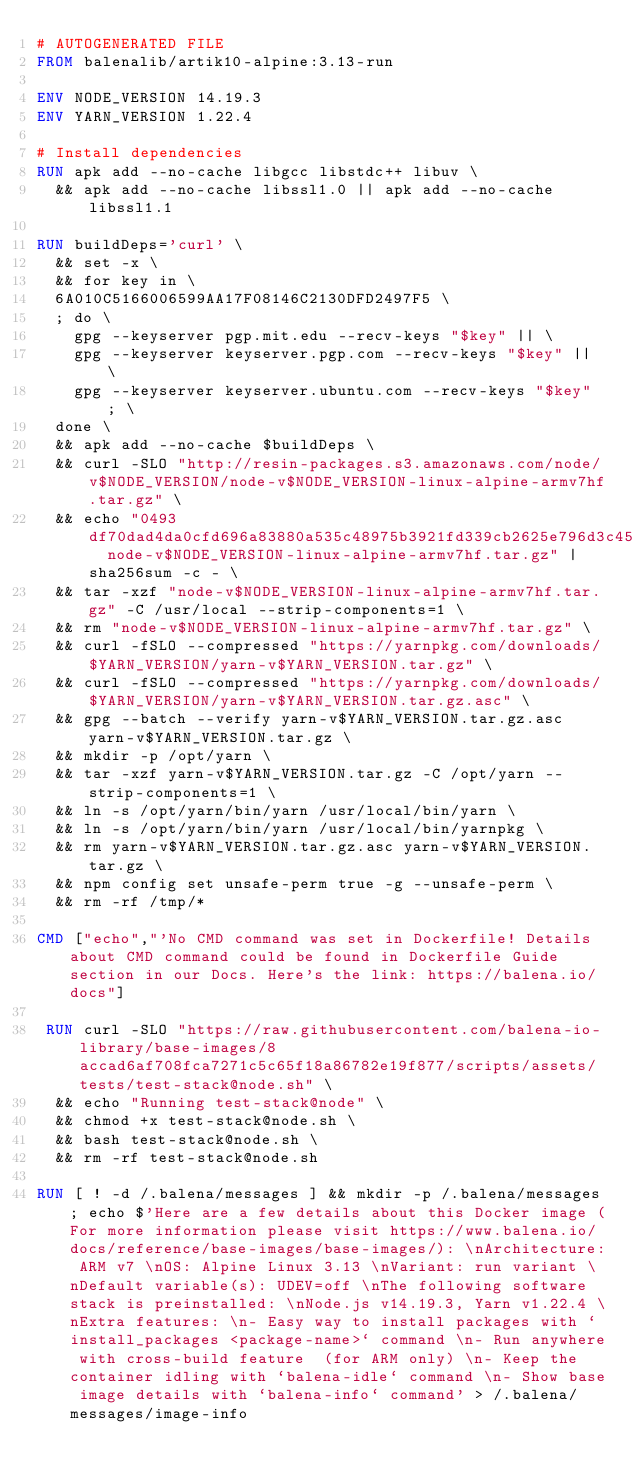<code> <loc_0><loc_0><loc_500><loc_500><_Dockerfile_># AUTOGENERATED FILE
FROM balenalib/artik10-alpine:3.13-run

ENV NODE_VERSION 14.19.3
ENV YARN_VERSION 1.22.4

# Install dependencies
RUN apk add --no-cache libgcc libstdc++ libuv \
	&& apk add --no-cache libssl1.0 || apk add --no-cache libssl1.1

RUN buildDeps='curl' \
	&& set -x \
	&& for key in \
	6A010C5166006599AA17F08146C2130DFD2497F5 \
	; do \
		gpg --keyserver pgp.mit.edu --recv-keys "$key" || \
		gpg --keyserver keyserver.pgp.com --recv-keys "$key" || \
		gpg --keyserver keyserver.ubuntu.com --recv-keys "$key" ; \
	done \
	&& apk add --no-cache $buildDeps \
	&& curl -SLO "http://resin-packages.s3.amazonaws.com/node/v$NODE_VERSION/node-v$NODE_VERSION-linux-alpine-armv7hf.tar.gz" \
	&& echo "0493df70dad4da0cfd696a83880a535c48975b3921fd339cb2625e796d3c45fe  node-v$NODE_VERSION-linux-alpine-armv7hf.tar.gz" | sha256sum -c - \
	&& tar -xzf "node-v$NODE_VERSION-linux-alpine-armv7hf.tar.gz" -C /usr/local --strip-components=1 \
	&& rm "node-v$NODE_VERSION-linux-alpine-armv7hf.tar.gz" \
	&& curl -fSLO --compressed "https://yarnpkg.com/downloads/$YARN_VERSION/yarn-v$YARN_VERSION.tar.gz" \
	&& curl -fSLO --compressed "https://yarnpkg.com/downloads/$YARN_VERSION/yarn-v$YARN_VERSION.tar.gz.asc" \
	&& gpg --batch --verify yarn-v$YARN_VERSION.tar.gz.asc yarn-v$YARN_VERSION.tar.gz \
	&& mkdir -p /opt/yarn \
	&& tar -xzf yarn-v$YARN_VERSION.tar.gz -C /opt/yarn --strip-components=1 \
	&& ln -s /opt/yarn/bin/yarn /usr/local/bin/yarn \
	&& ln -s /opt/yarn/bin/yarn /usr/local/bin/yarnpkg \
	&& rm yarn-v$YARN_VERSION.tar.gz.asc yarn-v$YARN_VERSION.tar.gz \
	&& npm config set unsafe-perm true -g --unsafe-perm \
	&& rm -rf /tmp/*

CMD ["echo","'No CMD command was set in Dockerfile! Details about CMD command could be found in Dockerfile Guide section in our Docs. Here's the link: https://balena.io/docs"]

 RUN curl -SLO "https://raw.githubusercontent.com/balena-io-library/base-images/8accad6af708fca7271c5c65f18a86782e19f877/scripts/assets/tests/test-stack@node.sh" \
  && echo "Running test-stack@node" \
  && chmod +x test-stack@node.sh \
  && bash test-stack@node.sh \
  && rm -rf test-stack@node.sh 

RUN [ ! -d /.balena/messages ] && mkdir -p /.balena/messages; echo $'Here are a few details about this Docker image (For more information please visit https://www.balena.io/docs/reference/base-images/base-images/): \nArchitecture: ARM v7 \nOS: Alpine Linux 3.13 \nVariant: run variant \nDefault variable(s): UDEV=off \nThe following software stack is preinstalled: \nNode.js v14.19.3, Yarn v1.22.4 \nExtra features: \n- Easy way to install packages with `install_packages <package-name>` command \n- Run anywhere with cross-build feature  (for ARM only) \n- Keep the container idling with `balena-idle` command \n- Show base image details with `balena-info` command' > /.balena/messages/image-info</code> 